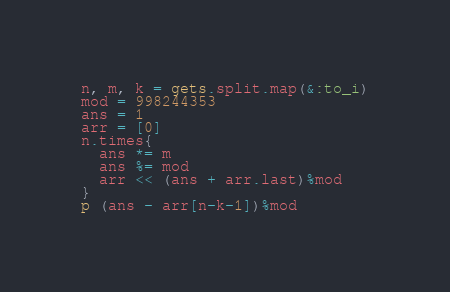Convert code to text. <code><loc_0><loc_0><loc_500><loc_500><_Ruby_>n, m, k = gets.split.map(&:to_i)
mod = 998244353
ans = 1
arr = [0]
n.times{
  ans *= m
  ans %= mod
  arr << (ans + arr.last)%mod
}
p (ans - arr[n-k-1])%mod
</code> 